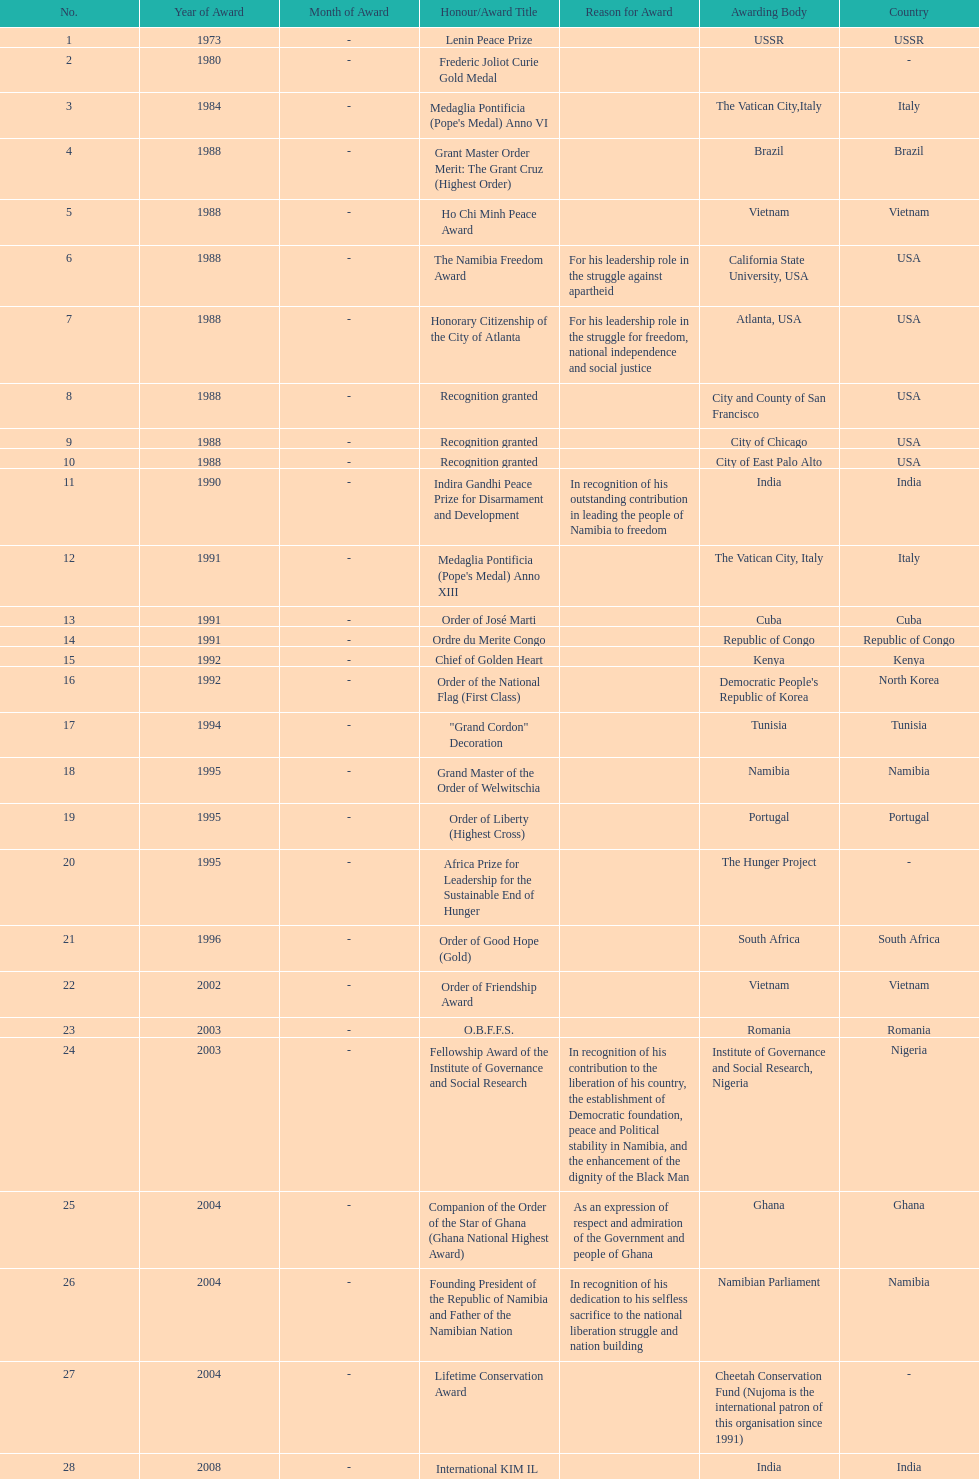Which year was the most honors/award titles given? 1988. 